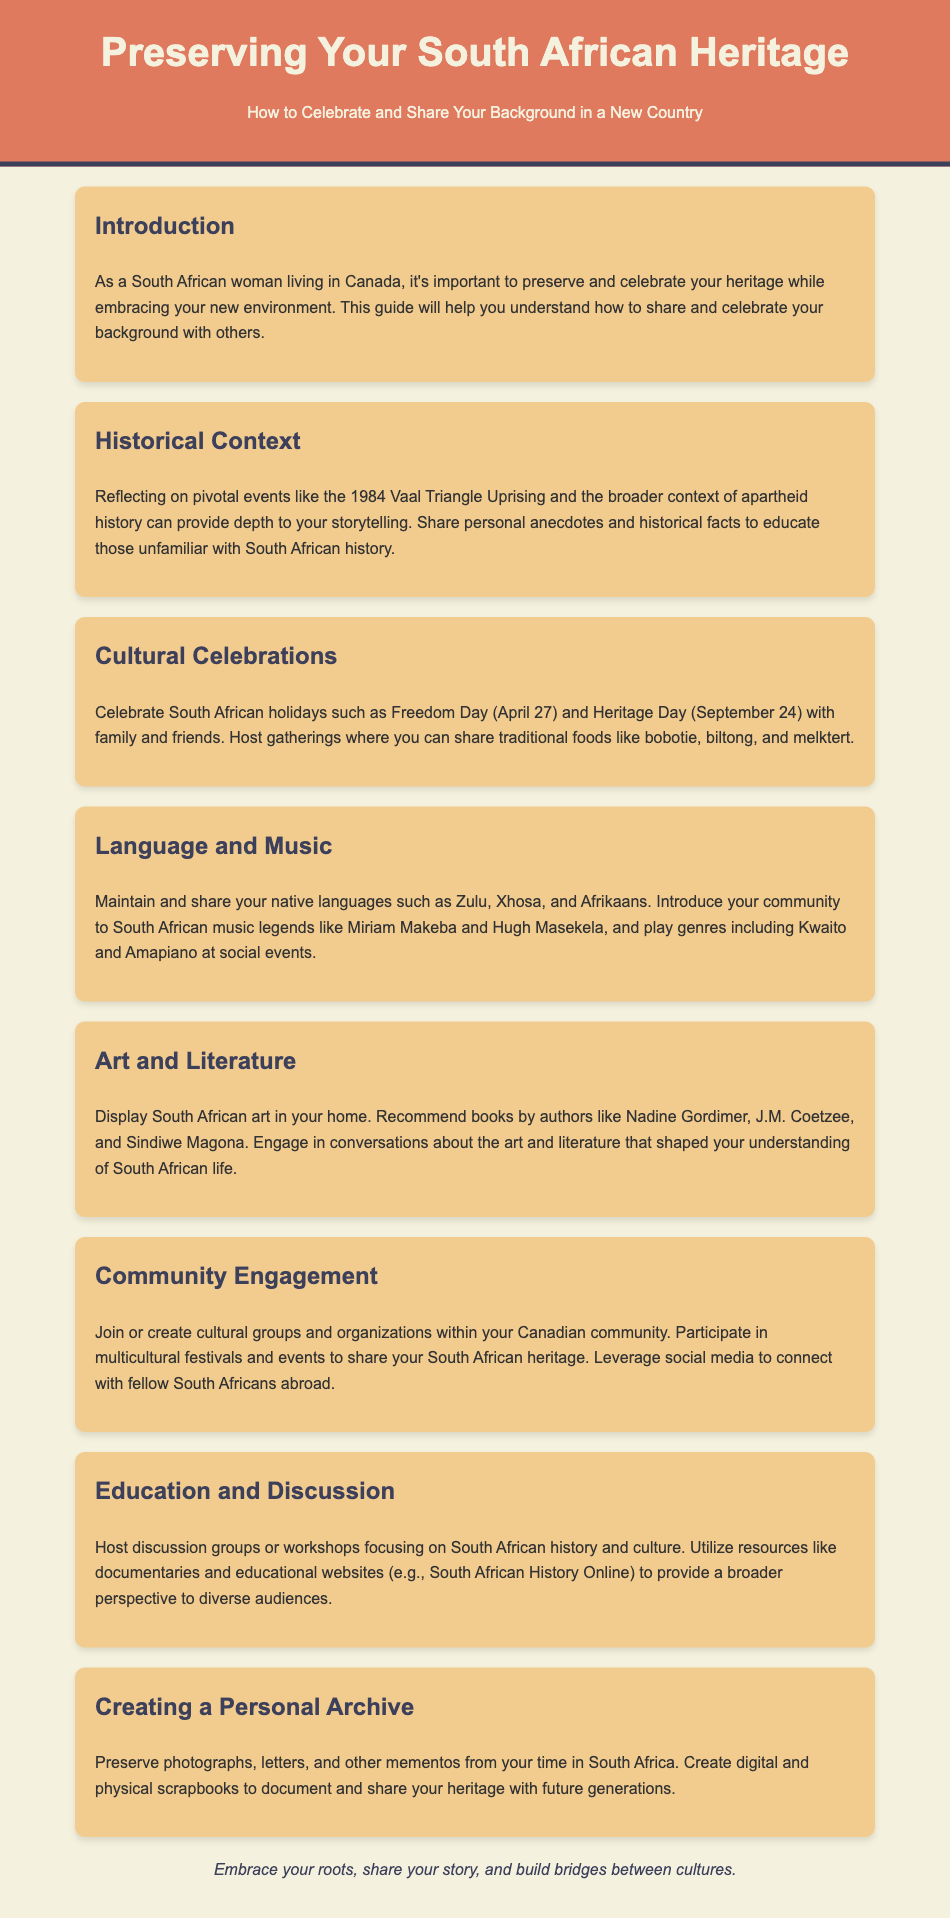what is the title of the guide? The title of the guide is presented prominently in the header section of the document.
Answer: Preserving Your South African Heritage what is the main theme of the introduction? The introduction emphasizes the importance of preserving and celebrating heritage while embracing a new environment.
Answer: Preserving and celebrating heritage how often is Freedom Day celebrated? Freedom Day occurs on a specific date which is noted in the cultural celebrations section.
Answer: April 27 who are two South African music legends mentioned in the document? The document lists specific musicians that represent South African music culture.
Answer: Miriam Makeba and Hugh Masekela which authors are recommended for South African literature? The guide provides a list of authors whose works are highlighted in relation to South African literature.
Answer: Nadine Gordimer, J.M. Coetzee, Sindiwe Magona what is one recommended activity for community engagement? The document suggests activities that promote cultural engagement and sharing.
Answer: Participate in multicultural festivals what can be preserved in a personal archive? The document lists types of items that individuals are encouraged to preserve as part of their heritage.
Answer: Photographs, letters, mementos how should one educate others about South African history? The document hints at methods used to share knowledge about South African culture and history.
Answer: Host discussion groups or workshops what is the date of Heritage Day? Heritage Day has a specific date noted in the cultural celebrations section of the document.
Answer: September 24 